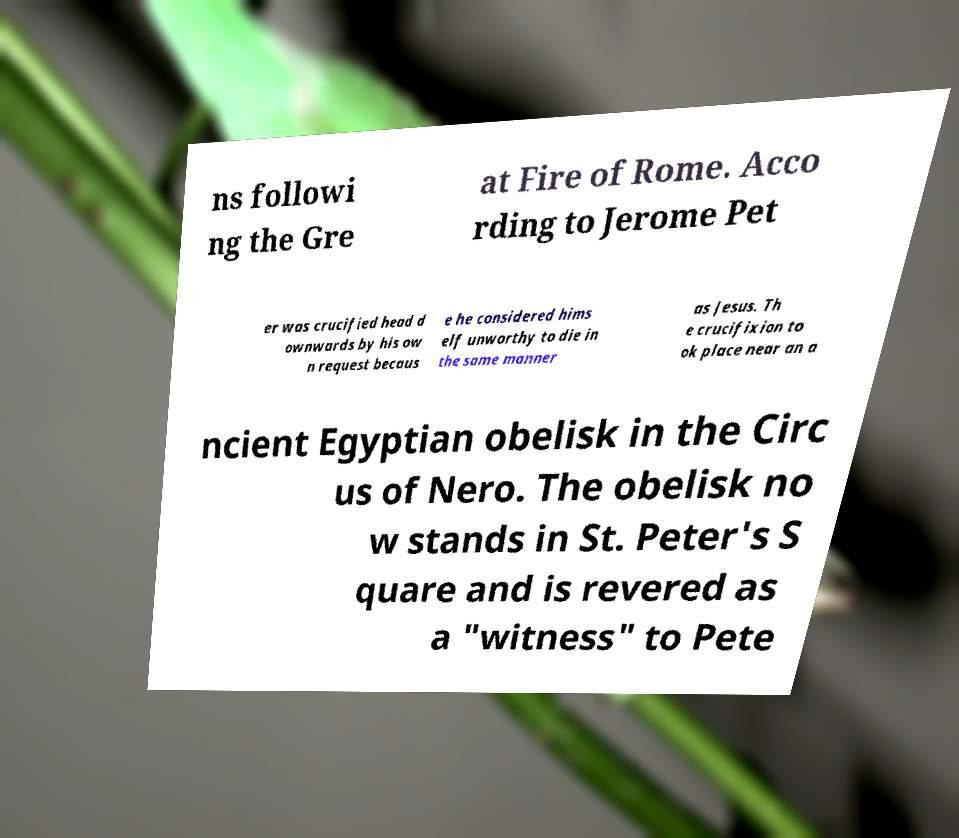Can you read and provide the text displayed in the image?This photo seems to have some interesting text. Can you extract and type it out for me? ns followi ng the Gre at Fire of Rome. Acco rding to Jerome Pet er was crucified head d ownwards by his ow n request becaus e he considered hims elf unworthy to die in the same manner as Jesus. Th e crucifixion to ok place near an a ncient Egyptian obelisk in the Circ us of Nero. The obelisk no w stands in St. Peter's S quare and is revered as a "witness" to Pete 